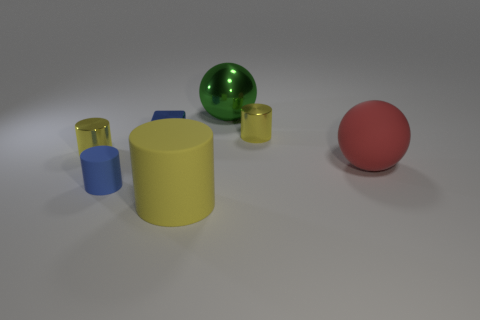What is the material of the cylinder that is in front of the red rubber sphere and behind the big yellow matte object?
Your response must be concise. Rubber. There is a blue cube that is the same size as the blue cylinder; what is it made of?
Provide a succinct answer. Metal. How big is the yellow shiny cylinder that is to the left of the tiny yellow thing right of the small yellow object that is to the left of the blue rubber cylinder?
Provide a short and direct response. Small. What is the size of the other cylinder that is the same material as the big yellow cylinder?
Offer a very short reply. Small. Does the metal sphere have the same size as the yellow object in front of the red thing?
Offer a terse response. Yes. There is a blue object that is behind the large red matte ball; what is its shape?
Make the answer very short. Cube. There is a shiny cylinder in front of the tiny yellow object right of the small blue rubber thing; are there any large red objects that are behind it?
Your answer should be compact. No. There is another big object that is the same shape as the blue rubber thing; what is it made of?
Offer a very short reply. Rubber. Is there anything else that is the same material as the blue cylinder?
Your answer should be compact. Yes. How many cylinders are tiny gray metallic objects or tiny matte objects?
Keep it short and to the point. 1. 